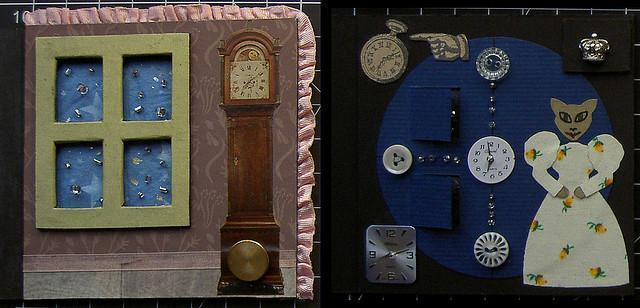How many circles?
Give a very brief answer. 6. 